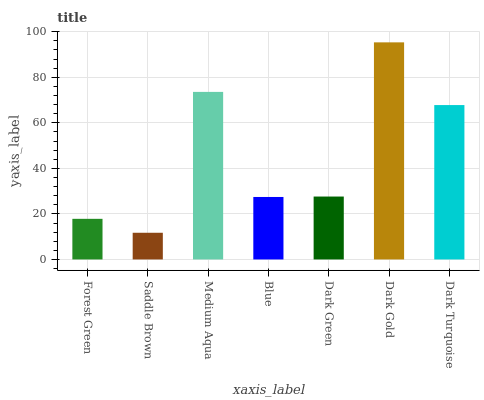Is Saddle Brown the minimum?
Answer yes or no. Yes. Is Dark Gold the maximum?
Answer yes or no. Yes. Is Medium Aqua the minimum?
Answer yes or no. No. Is Medium Aqua the maximum?
Answer yes or no. No. Is Medium Aqua greater than Saddle Brown?
Answer yes or no. Yes. Is Saddle Brown less than Medium Aqua?
Answer yes or no. Yes. Is Saddle Brown greater than Medium Aqua?
Answer yes or no. No. Is Medium Aqua less than Saddle Brown?
Answer yes or no. No. Is Dark Green the high median?
Answer yes or no. Yes. Is Dark Green the low median?
Answer yes or no. Yes. Is Medium Aqua the high median?
Answer yes or no. No. Is Blue the low median?
Answer yes or no. No. 